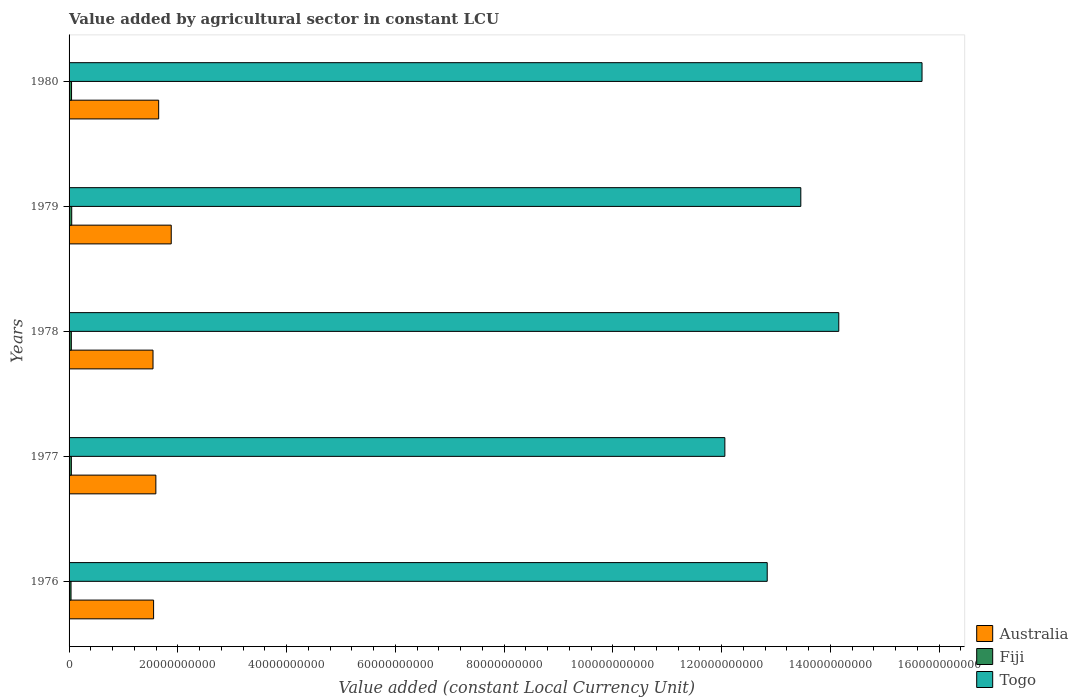Are the number of bars per tick equal to the number of legend labels?
Ensure brevity in your answer.  Yes. Are the number of bars on each tick of the Y-axis equal?
Your answer should be very brief. Yes. What is the label of the 2nd group of bars from the top?
Your answer should be compact. 1979. In how many cases, is the number of bars for a given year not equal to the number of legend labels?
Keep it short and to the point. 0. What is the value added by agricultural sector in Australia in 1980?
Ensure brevity in your answer.  1.65e+1. Across all years, what is the maximum value added by agricultural sector in Togo?
Give a very brief answer. 1.57e+11. Across all years, what is the minimum value added by agricultural sector in Fiji?
Make the answer very short. 3.62e+08. In which year was the value added by agricultural sector in Fiji maximum?
Provide a succinct answer. 1979. In which year was the value added by agricultural sector in Australia minimum?
Provide a short and direct response. 1978. What is the total value added by agricultural sector in Australia in the graph?
Make the answer very short. 8.22e+1. What is the difference between the value added by agricultural sector in Togo in 1976 and that in 1980?
Keep it short and to the point. -2.85e+1. What is the difference between the value added by agricultural sector in Togo in 1979 and the value added by agricultural sector in Fiji in 1977?
Provide a short and direct response. 1.34e+11. What is the average value added by agricultural sector in Fiji per year?
Keep it short and to the point. 4.27e+08. In the year 1977, what is the difference between the value added by agricultural sector in Fiji and value added by agricultural sector in Australia?
Your answer should be very brief. -1.55e+1. What is the ratio of the value added by agricultural sector in Australia in 1978 to that in 1979?
Offer a terse response. 0.82. Is the value added by agricultural sector in Australia in 1977 less than that in 1978?
Give a very brief answer. No. What is the difference between the highest and the second highest value added by agricultural sector in Australia?
Make the answer very short. 2.31e+09. What is the difference between the highest and the lowest value added by agricultural sector in Australia?
Your answer should be very brief. 3.35e+09. What does the 2nd bar from the top in 1977 represents?
Provide a succinct answer. Fiji. What does the 3rd bar from the bottom in 1976 represents?
Your response must be concise. Togo. Is it the case that in every year, the sum of the value added by agricultural sector in Togo and value added by agricultural sector in Australia is greater than the value added by agricultural sector in Fiji?
Provide a short and direct response. Yes. How many bars are there?
Your answer should be compact. 15. Are all the bars in the graph horizontal?
Your response must be concise. Yes. What is the difference between two consecutive major ticks on the X-axis?
Provide a succinct answer. 2.00e+1. Does the graph contain any zero values?
Your answer should be compact. No. How many legend labels are there?
Make the answer very short. 3. How are the legend labels stacked?
Give a very brief answer. Vertical. What is the title of the graph?
Give a very brief answer. Value added by agricultural sector in constant LCU. What is the label or title of the X-axis?
Provide a succinct answer. Value added (constant Local Currency Unit). What is the Value added (constant Local Currency Unit) of Australia in 1976?
Provide a succinct answer. 1.55e+1. What is the Value added (constant Local Currency Unit) in Fiji in 1976?
Offer a terse response. 3.62e+08. What is the Value added (constant Local Currency Unit) in Togo in 1976?
Your answer should be very brief. 1.28e+11. What is the Value added (constant Local Currency Unit) of Australia in 1977?
Offer a terse response. 1.60e+1. What is the Value added (constant Local Currency Unit) of Fiji in 1977?
Offer a very short reply. 4.20e+08. What is the Value added (constant Local Currency Unit) in Togo in 1977?
Give a very brief answer. 1.21e+11. What is the Value added (constant Local Currency Unit) in Australia in 1978?
Your answer should be very brief. 1.54e+1. What is the Value added (constant Local Currency Unit) of Fiji in 1978?
Your answer should be compact. 4.15e+08. What is the Value added (constant Local Currency Unit) in Togo in 1978?
Your answer should be compact. 1.42e+11. What is the Value added (constant Local Currency Unit) in Australia in 1979?
Your answer should be very brief. 1.88e+1. What is the Value added (constant Local Currency Unit) in Fiji in 1979?
Your response must be concise. 4.86e+08. What is the Value added (constant Local Currency Unit) in Togo in 1979?
Ensure brevity in your answer.  1.35e+11. What is the Value added (constant Local Currency Unit) of Australia in 1980?
Keep it short and to the point. 1.65e+1. What is the Value added (constant Local Currency Unit) in Fiji in 1980?
Give a very brief answer. 4.54e+08. What is the Value added (constant Local Currency Unit) in Togo in 1980?
Your answer should be compact. 1.57e+11. Across all years, what is the maximum Value added (constant Local Currency Unit) of Australia?
Provide a short and direct response. 1.88e+1. Across all years, what is the maximum Value added (constant Local Currency Unit) of Fiji?
Provide a short and direct response. 4.86e+08. Across all years, what is the maximum Value added (constant Local Currency Unit) in Togo?
Your answer should be very brief. 1.57e+11. Across all years, what is the minimum Value added (constant Local Currency Unit) in Australia?
Your answer should be compact. 1.54e+1. Across all years, what is the minimum Value added (constant Local Currency Unit) in Fiji?
Offer a terse response. 3.62e+08. Across all years, what is the minimum Value added (constant Local Currency Unit) of Togo?
Your answer should be compact. 1.21e+11. What is the total Value added (constant Local Currency Unit) of Australia in the graph?
Provide a short and direct response. 8.22e+1. What is the total Value added (constant Local Currency Unit) in Fiji in the graph?
Offer a terse response. 2.14e+09. What is the total Value added (constant Local Currency Unit) in Togo in the graph?
Provide a short and direct response. 6.82e+11. What is the difference between the Value added (constant Local Currency Unit) of Australia in 1976 and that in 1977?
Your response must be concise. -4.16e+08. What is the difference between the Value added (constant Local Currency Unit) of Fiji in 1976 and that in 1977?
Offer a terse response. -5.83e+07. What is the difference between the Value added (constant Local Currency Unit) in Togo in 1976 and that in 1977?
Give a very brief answer. 7.79e+09. What is the difference between the Value added (constant Local Currency Unit) of Australia in 1976 and that in 1978?
Ensure brevity in your answer.  1.07e+08. What is the difference between the Value added (constant Local Currency Unit) in Fiji in 1976 and that in 1978?
Offer a terse response. -5.29e+07. What is the difference between the Value added (constant Local Currency Unit) of Togo in 1976 and that in 1978?
Give a very brief answer. -1.32e+1. What is the difference between the Value added (constant Local Currency Unit) of Australia in 1976 and that in 1979?
Keep it short and to the point. -3.24e+09. What is the difference between the Value added (constant Local Currency Unit) of Fiji in 1976 and that in 1979?
Keep it short and to the point. -1.24e+08. What is the difference between the Value added (constant Local Currency Unit) of Togo in 1976 and that in 1979?
Provide a short and direct response. -6.18e+09. What is the difference between the Value added (constant Local Currency Unit) of Australia in 1976 and that in 1980?
Your response must be concise. -9.34e+08. What is the difference between the Value added (constant Local Currency Unit) in Fiji in 1976 and that in 1980?
Give a very brief answer. -9.24e+07. What is the difference between the Value added (constant Local Currency Unit) in Togo in 1976 and that in 1980?
Make the answer very short. -2.85e+1. What is the difference between the Value added (constant Local Currency Unit) in Australia in 1977 and that in 1978?
Provide a succinct answer. 5.23e+08. What is the difference between the Value added (constant Local Currency Unit) in Fiji in 1977 and that in 1978?
Ensure brevity in your answer.  5.35e+06. What is the difference between the Value added (constant Local Currency Unit) of Togo in 1977 and that in 1978?
Ensure brevity in your answer.  -2.10e+1. What is the difference between the Value added (constant Local Currency Unit) in Australia in 1977 and that in 1979?
Offer a very short reply. -2.83e+09. What is the difference between the Value added (constant Local Currency Unit) in Fiji in 1977 and that in 1979?
Your answer should be very brief. -6.57e+07. What is the difference between the Value added (constant Local Currency Unit) of Togo in 1977 and that in 1979?
Make the answer very short. -1.40e+1. What is the difference between the Value added (constant Local Currency Unit) in Australia in 1977 and that in 1980?
Ensure brevity in your answer.  -5.18e+08. What is the difference between the Value added (constant Local Currency Unit) of Fiji in 1977 and that in 1980?
Give a very brief answer. -3.42e+07. What is the difference between the Value added (constant Local Currency Unit) of Togo in 1977 and that in 1980?
Ensure brevity in your answer.  -3.63e+1. What is the difference between the Value added (constant Local Currency Unit) of Australia in 1978 and that in 1979?
Offer a very short reply. -3.35e+09. What is the difference between the Value added (constant Local Currency Unit) of Fiji in 1978 and that in 1979?
Make the answer very short. -7.10e+07. What is the difference between the Value added (constant Local Currency Unit) in Togo in 1978 and that in 1979?
Ensure brevity in your answer.  6.98e+09. What is the difference between the Value added (constant Local Currency Unit) in Australia in 1978 and that in 1980?
Offer a very short reply. -1.04e+09. What is the difference between the Value added (constant Local Currency Unit) in Fiji in 1978 and that in 1980?
Provide a short and direct response. -3.95e+07. What is the difference between the Value added (constant Local Currency Unit) of Togo in 1978 and that in 1980?
Your response must be concise. -1.53e+1. What is the difference between the Value added (constant Local Currency Unit) of Australia in 1979 and that in 1980?
Your answer should be very brief. 2.31e+09. What is the difference between the Value added (constant Local Currency Unit) of Fiji in 1979 and that in 1980?
Give a very brief answer. 3.15e+07. What is the difference between the Value added (constant Local Currency Unit) of Togo in 1979 and that in 1980?
Your answer should be very brief. -2.23e+1. What is the difference between the Value added (constant Local Currency Unit) of Australia in 1976 and the Value added (constant Local Currency Unit) of Fiji in 1977?
Offer a very short reply. 1.51e+1. What is the difference between the Value added (constant Local Currency Unit) in Australia in 1976 and the Value added (constant Local Currency Unit) in Togo in 1977?
Offer a terse response. -1.05e+11. What is the difference between the Value added (constant Local Currency Unit) in Fiji in 1976 and the Value added (constant Local Currency Unit) in Togo in 1977?
Provide a succinct answer. -1.20e+11. What is the difference between the Value added (constant Local Currency Unit) in Australia in 1976 and the Value added (constant Local Currency Unit) in Fiji in 1978?
Offer a very short reply. 1.51e+1. What is the difference between the Value added (constant Local Currency Unit) of Australia in 1976 and the Value added (constant Local Currency Unit) of Togo in 1978?
Provide a succinct answer. -1.26e+11. What is the difference between the Value added (constant Local Currency Unit) of Fiji in 1976 and the Value added (constant Local Currency Unit) of Togo in 1978?
Provide a short and direct response. -1.41e+11. What is the difference between the Value added (constant Local Currency Unit) of Australia in 1976 and the Value added (constant Local Currency Unit) of Fiji in 1979?
Your response must be concise. 1.51e+1. What is the difference between the Value added (constant Local Currency Unit) of Australia in 1976 and the Value added (constant Local Currency Unit) of Togo in 1979?
Your answer should be very brief. -1.19e+11. What is the difference between the Value added (constant Local Currency Unit) in Fiji in 1976 and the Value added (constant Local Currency Unit) in Togo in 1979?
Make the answer very short. -1.34e+11. What is the difference between the Value added (constant Local Currency Unit) in Australia in 1976 and the Value added (constant Local Currency Unit) in Fiji in 1980?
Your answer should be compact. 1.51e+1. What is the difference between the Value added (constant Local Currency Unit) in Australia in 1976 and the Value added (constant Local Currency Unit) in Togo in 1980?
Your answer should be compact. -1.41e+11. What is the difference between the Value added (constant Local Currency Unit) of Fiji in 1976 and the Value added (constant Local Currency Unit) of Togo in 1980?
Your answer should be compact. -1.56e+11. What is the difference between the Value added (constant Local Currency Unit) of Australia in 1977 and the Value added (constant Local Currency Unit) of Fiji in 1978?
Offer a terse response. 1.55e+1. What is the difference between the Value added (constant Local Currency Unit) of Australia in 1977 and the Value added (constant Local Currency Unit) of Togo in 1978?
Provide a succinct answer. -1.26e+11. What is the difference between the Value added (constant Local Currency Unit) of Fiji in 1977 and the Value added (constant Local Currency Unit) of Togo in 1978?
Provide a succinct answer. -1.41e+11. What is the difference between the Value added (constant Local Currency Unit) in Australia in 1977 and the Value added (constant Local Currency Unit) in Fiji in 1979?
Give a very brief answer. 1.55e+1. What is the difference between the Value added (constant Local Currency Unit) of Australia in 1977 and the Value added (constant Local Currency Unit) of Togo in 1979?
Your answer should be compact. -1.19e+11. What is the difference between the Value added (constant Local Currency Unit) in Fiji in 1977 and the Value added (constant Local Currency Unit) in Togo in 1979?
Make the answer very short. -1.34e+11. What is the difference between the Value added (constant Local Currency Unit) of Australia in 1977 and the Value added (constant Local Currency Unit) of Fiji in 1980?
Your response must be concise. 1.55e+1. What is the difference between the Value added (constant Local Currency Unit) of Australia in 1977 and the Value added (constant Local Currency Unit) of Togo in 1980?
Give a very brief answer. -1.41e+11. What is the difference between the Value added (constant Local Currency Unit) in Fiji in 1977 and the Value added (constant Local Currency Unit) in Togo in 1980?
Provide a succinct answer. -1.56e+11. What is the difference between the Value added (constant Local Currency Unit) in Australia in 1978 and the Value added (constant Local Currency Unit) in Fiji in 1979?
Your answer should be compact. 1.50e+1. What is the difference between the Value added (constant Local Currency Unit) of Australia in 1978 and the Value added (constant Local Currency Unit) of Togo in 1979?
Your answer should be very brief. -1.19e+11. What is the difference between the Value added (constant Local Currency Unit) in Fiji in 1978 and the Value added (constant Local Currency Unit) in Togo in 1979?
Your answer should be very brief. -1.34e+11. What is the difference between the Value added (constant Local Currency Unit) in Australia in 1978 and the Value added (constant Local Currency Unit) in Fiji in 1980?
Your answer should be compact. 1.50e+1. What is the difference between the Value added (constant Local Currency Unit) of Australia in 1978 and the Value added (constant Local Currency Unit) of Togo in 1980?
Make the answer very short. -1.41e+11. What is the difference between the Value added (constant Local Currency Unit) of Fiji in 1978 and the Value added (constant Local Currency Unit) of Togo in 1980?
Give a very brief answer. -1.56e+11. What is the difference between the Value added (constant Local Currency Unit) of Australia in 1979 and the Value added (constant Local Currency Unit) of Fiji in 1980?
Give a very brief answer. 1.83e+1. What is the difference between the Value added (constant Local Currency Unit) in Australia in 1979 and the Value added (constant Local Currency Unit) in Togo in 1980?
Ensure brevity in your answer.  -1.38e+11. What is the difference between the Value added (constant Local Currency Unit) of Fiji in 1979 and the Value added (constant Local Currency Unit) of Togo in 1980?
Your answer should be very brief. -1.56e+11. What is the average Value added (constant Local Currency Unit) in Australia per year?
Provide a short and direct response. 1.64e+1. What is the average Value added (constant Local Currency Unit) in Fiji per year?
Your response must be concise. 4.27e+08. What is the average Value added (constant Local Currency Unit) in Togo per year?
Offer a very short reply. 1.36e+11. In the year 1976, what is the difference between the Value added (constant Local Currency Unit) in Australia and Value added (constant Local Currency Unit) in Fiji?
Your answer should be very brief. 1.52e+1. In the year 1976, what is the difference between the Value added (constant Local Currency Unit) in Australia and Value added (constant Local Currency Unit) in Togo?
Offer a very short reply. -1.13e+11. In the year 1976, what is the difference between the Value added (constant Local Currency Unit) in Fiji and Value added (constant Local Currency Unit) in Togo?
Your answer should be very brief. -1.28e+11. In the year 1977, what is the difference between the Value added (constant Local Currency Unit) in Australia and Value added (constant Local Currency Unit) in Fiji?
Make the answer very short. 1.55e+1. In the year 1977, what is the difference between the Value added (constant Local Currency Unit) in Australia and Value added (constant Local Currency Unit) in Togo?
Your answer should be compact. -1.05e+11. In the year 1977, what is the difference between the Value added (constant Local Currency Unit) of Fiji and Value added (constant Local Currency Unit) of Togo?
Give a very brief answer. -1.20e+11. In the year 1978, what is the difference between the Value added (constant Local Currency Unit) of Australia and Value added (constant Local Currency Unit) of Fiji?
Provide a succinct answer. 1.50e+1. In the year 1978, what is the difference between the Value added (constant Local Currency Unit) in Australia and Value added (constant Local Currency Unit) in Togo?
Offer a very short reply. -1.26e+11. In the year 1978, what is the difference between the Value added (constant Local Currency Unit) in Fiji and Value added (constant Local Currency Unit) in Togo?
Provide a succinct answer. -1.41e+11. In the year 1979, what is the difference between the Value added (constant Local Currency Unit) in Australia and Value added (constant Local Currency Unit) in Fiji?
Provide a short and direct response. 1.83e+1. In the year 1979, what is the difference between the Value added (constant Local Currency Unit) in Australia and Value added (constant Local Currency Unit) in Togo?
Offer a very short reply. -1.16e+11. In the year 1979, what is the difference between the Value added (constant Local Currency Unit) of Fiji and Value added (constant Local Currency Unit) of Togo?
Your response must be concise. -1.34e+11. In the year 1980, what is the difference between the Value added (constant Local Currency Unit) in Australia and Value added (constant Local Currency Unit) in Fiji?
Make the answer very short. 1.60e+1. In the year 1980, what is the difference between the Value added (constant Local Currency Unit) in Australia and Value added (constant Local Currency Unit) in Togo?
Give a very brief answer. -1.40e+11. In the year 1980, what is the difference between the Value added (constant Local Currency Unit) in Fiji and Value added (constant Local Currency Unit) in Togo?
Keep it short and to the point. -1.56e+11. What is the ratio of the Value added (constant Local Currency Unit) in Australia in 1976 to that in 1977?
Give a very brief answer. 0.97. What is the ratio of the Value added (constant Local Currency Unit) in Fiji in 1976 to that in 1977?
Offer a terse response. 0.86. What is the ratio of the Value added (constant Local Currency Unit) of Togo in 1976 to that in 1977?
Ensure brevity in your answer.  1.06. What is the ratio of the Value added (constant Local Currency Unit) in Australia in 1976 to that in 1978?
Your answer should be compact. 1.01. What is the ratio of the Value added (constant Local Currency Unit) of Fiji in 1976 to that in 1978?
Your response must be concise. 0.87. What is the ratio of the Value added (constant Local Currency Unit) of Togo in 1976 to that in 1978?
Offer a terse response. 0.91. What is the ratio of the Value added (constant Local Currency Unit) of Australia in 1976 to that in 1979?
Provide a short and direct response. 0.83. What is the ratio of the Value added (constant Local Currency Unit) in Fiji in 1976 to that in 1979?
Make the answer very short. 0.74. What is the ratio of the Value added (constant Local Currency Unit) in Togo in 1976 to that in 1979?
Give a very brief answer. 0.95. What is the ratio of the Value added (constant Local Currency Unit) of Australia in 1976 to that in 1980?
Provide a short and direct response. 0.94. What is the ratio of the Value added (constant Local Currency Unit) in Fiji in 1976 to that in 1980?
Offer a terse response. 0.8. What is the ratio of the Value added (constant Local Currency Unit) of Togo in 1976 to that in 1980?
Provide a short and direct response. 0.82. What is the ratio of the Value added (constant Local Currency Unit) of Australia in 1977 to that in 1978?
Your answer should be compact. 1.03. What is the ratio of the Value added (constant Local Currency Unit) of Fiji in 1977 to that in 1978?
Provide a succinct answer. 1.01. What is the ratio of the Value added (constant Local Currency Unit) in Togo in 1977 to that in 1978?
Provide a succinct answer. 0.85. What is the ratio of the Value added (constant Local Currency Unit) in Australia in 1977 to that in 1979?
Provide a succinct answer. 0.85. What is the ratio of the Value added (constant Local Currency Unit) in Fiji in 1977 to that in 1979?
Make the answer very short. 0.86. What is the ratio of the Value added (constant Local Currency Unit) of Togo in 1977 to that in 1979?
Provide a short and direct response. 0.9. What is the ratio of the Value added (constant Local Currency Unit) in Australia in 1977 to that in 1980?
Provide a short and direct response. 0.97. What is the ratio of the Value added (constant Local Currency Unit) in Fiji in 1977 to that in 1980?
Make the answer very short. 0.92. What is the ratio of the Value added (constant Local Currency Unit) of Togo in 1977 to that in 1980?
Your answer should be compact. 0.77. What is the ratio of the Value added (constant Local Currency Unit) of Australia in 1978 to that in 1979?
Ensure brevity in your answer.  0.82. What is the ratio of the Value added (constant Local Currency Unit) of Fiji in 1978 to that in 1979?
Ensure brevity in your answer.  0.85. What is the ratio of the Value added (constant Local Currency Unit) of Togo in 1978 to that in 1979?
Your response must be concise. 1.05. What is the ratio of the Value added (constant Local Currency Unit) of Australia in 1978 to that in 1980?
Offer a very short reply. 0.94. What is the ratio of the Value added (constant Local Currency Unit) of Togo in 1978 to that in 1980?
Offer a terse response. 0.9. What is the ratio of the Value added (constant Local Currency Unit) in Australia in 1979 to that in 1980?
Provide a short and direct response. 1.14. What is the ratio of the Value added (constant Local Currency Unit) of Fiji in 1979 to that in 1980?
Your response must be concise. 1.07. What is the ratio of the Value added (constant Local Currency Unit) of Togo in 1979 to that in 1980?
Your response must be concise. 0.86. What is the difference between the highest and the second highest Value added (constant Local Currency Unit) in Australia?
Provide a short and direct response. 2.31e+09. What is the difference between the highest and the second highest Value added (constant Local Currency Unit) of Fiji?
Your response must be concise. 3.15e+07. What is the difference between the highest and the second highest Value added (constant Local Currency Unit) of Togo?
Your answer should be very brief. 1.53e+1. What is the difference between the highest and the lowest Value added (constant Local Currency Unit) of Australia?
Provide a short and direct response. 3.35e+09. What is the difference between the highest and the lowest Value added (constant Local Currency Unit) in Fiji?
Ensure brevity in your answer.  1.24e+08. What is the difference between the highest and the lowest Value added (constant Local Currency Unit) in Togo?
Your answer should be very brief. 3.63e+1. 